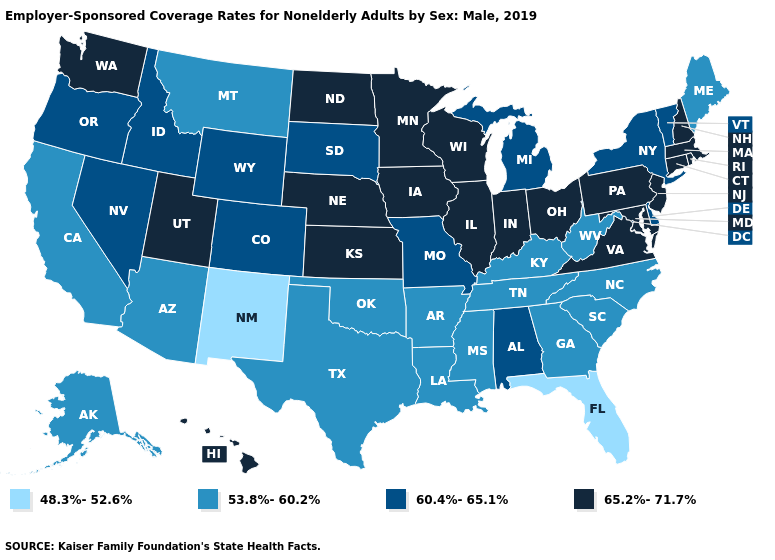Name the states that have a value in the range 53.8%-60.2%?
Concise answer only. Alaska, Arizona, Arkansas, California, Georgia, Kentucky, Louisiana, Maine, Mississippi, Montana, North Carolina, Oklahoma, South Carolina, Tennessee, Texas, West Virginia. Name the states that have a value in the range 53.8%-60.2%?
Short answer required. Alaska, Arizona, Arkansas, California, Georgia, Kentucky, Louisiana, Maine, Mississippi, Montana, North Carolina, Oklahoma, South Carolina, Tennessee, Texas, West Virginia. What is the highest value in the USA?
Quick response, please. 65.2%-71.7%. What is the value of Mississippi?
Keep it brief. 53.8%-60.2%. Does the map have missing data?
Answer briefly. No. Name the states that have a value in the range 60.4%-65.1%?
Give a very brief answer. Alabama, Colorado, Delaware, Idaho, Michigan, Missouri, Nevada, New York, Oregon, South Dakota, Vermont, Wyoming. Does New Mexico have the lowest value in the USA?
Quick response, please. Yes. What is the lowest value in the South?
Answer briefly. 48.3%-52.6%. Does Illinois have the lowest value in the USA?
Write a very short answer. No. What is the value of Colorado?
Answer briefly. 60.4%-65.1%. Does Georgia have the highest value in the USA?
Keep it brief. No. Name the states that have a value in the range 65.2%-71.7%?
Keep it brief. Connecticut, Hawaii, Illinois, Indiana, Iowa, Kansas, Maryland, Massachusetts, Minnesota, Nebraska, New Hampshire, New Jersey, North Dakota, Ohio, Pennsylvania, Rhode Island, Utah, Virginia, Washington, Wisconsin. Among the states that border New Mexico , which have the lowest value?
Short answer required. Arizona, Oklahoma, Texas. What is the value of Oklahoma?
Short answer required. 53.8%-60.2%. Is the legend a continuous bar?
Concise answer only. No. 